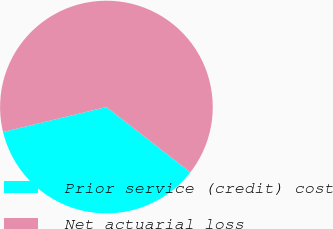Convert chart. <chart><loc_0><loc_0><loc_500><loc_500><pie_chart><fcel>Prior service (credit) cost<fcel>Net actuarial loss<nl><fcel>35.71%<fcel>64.29%<nl></chart> 